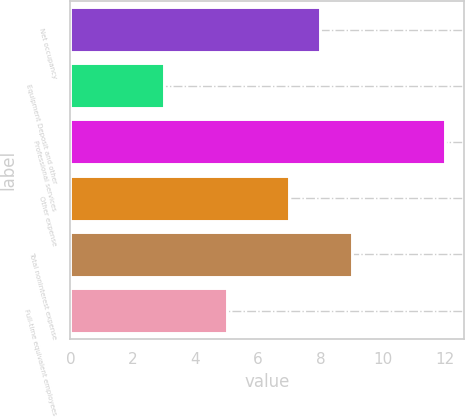Convert chart to OTSL. <chart><loc_0><loc_0><loc_500><loc_500><bar_chart><fcel>Net occupancy<fcel>Equipment Deposit and other<fcel>Professional services<fcel>Other expense<fcel>Total noninterest expense<fcel>Full-time equivalent employees<nl><fcel>8<fcel>3<fcel>12<fcel>7<fcel>9<fcel>5<nl></chart> 